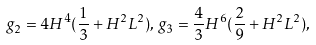<formula> <loc_0><loc_0><loc_500><loc_500>g _ { 2 } = 4 H ^ { 4 } ( \frac { 1 } { 3 } + H ^ { 2 } L ^ { 2 } ) , \, g _ { 3 } = \frac { 4 } { 3 } H ^ { 6 } ( \frac { 2 } { 9 } + H ^ { 2 } L ^ { 2 } ) ,</formula> 